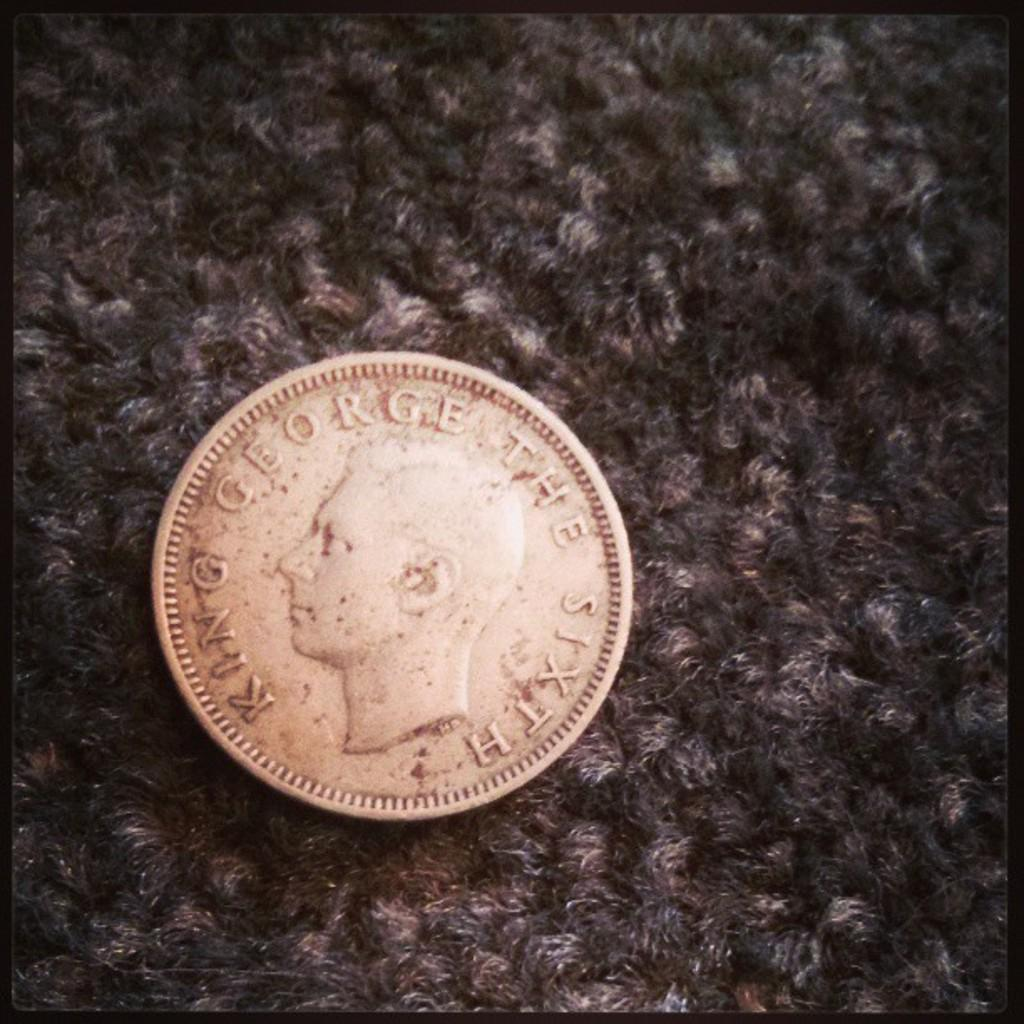Provide a one-sentence caption for the provided image. A silver coin on a carpeted background with King George The Sixth on its surface. 